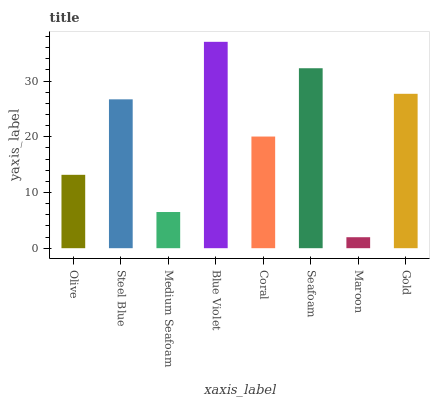Is Maroon the minimum?
Answer yes or no. Yes. Is Blue Violet the maximum?
Answer yes or no. Yes. Is Steel Blue the minimum?
Answer yes or no. No. Is Steel Blue the maximum?
Answer yes or no. No. Is Steel Blue greater than Olive?
Answer yes or no. Yes. Is Olive less than Steel Blue?
Answer yes or no. Yes. Is Olive greater than Steel Blue?
Answer yes or no. No. Is Steel Blue less than Olive?
Answer yes or no. No. Is Steel Blue the high median?
Answer yes or no. Yes. Is Coral the low median?
Answer yes or no. Yes. Is Blue Violet the high median?
Answer yes or no. No. Is Olive the low median?
Answer yes or no. No. 